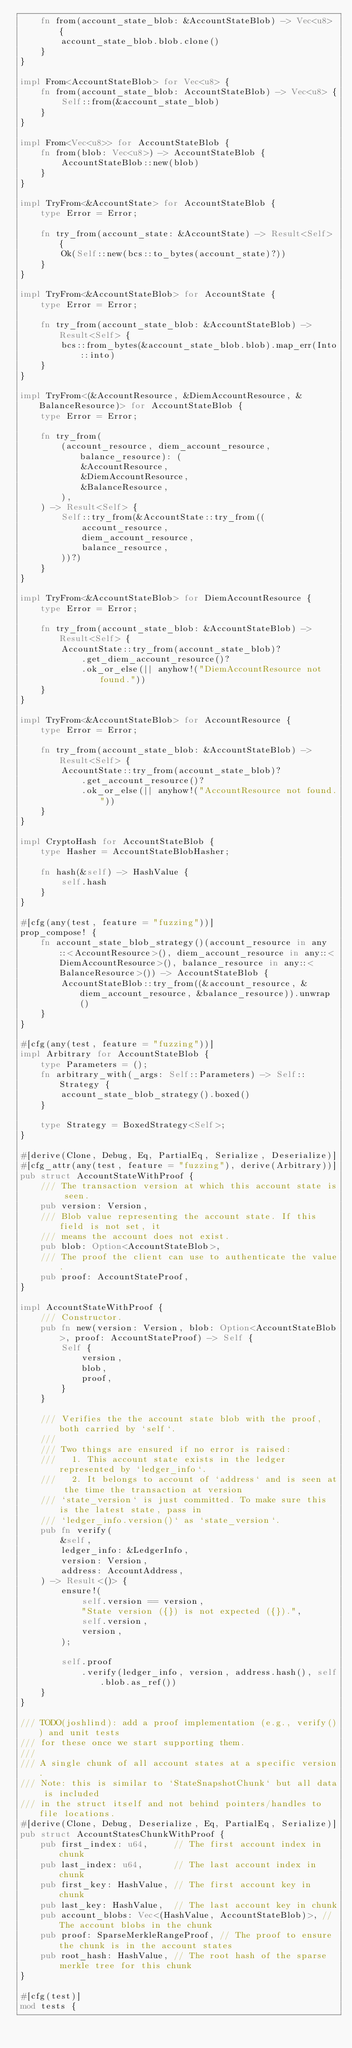Convert code to text. <code><loc_0><loc_0><loc_500><loc_500><_Rust_>    fn from(account_state_blob: &AccountStateBlob) -> Vec<u8> {
        account_state_blob.blob.clone()
    }
}

impl From<AccountStateBlob> for Vec<u8> {
    fn from(account_state_blob: AccountStateBlob) -> Vec<u8> {
        Self::from(&account_state_blob)
    }
}

impl From<Vec<u8>> for AccountStateBlob {
    fn from(blob: Vec<u8>) -> AccountStateBlob {
        AccountStateBlob::new(blob)
    }
}

impl TryFrom<&AccountState> for AccountStateBlob {
    type Error = Error;

    fn try_from(account_state: &AccountState) -> Result<Self> {
        Ok(Self::new(bcs::to_bytes(account_state)?))
    }
}

impl TryFrom<&AccountStateBlob> for AccountState {
    type Error = Error;

    fn try_from(account_state_blob: &AccountStateBlob) -> Result<Self> {
        bcs::from_bytes(&account_state_blob.blob).map_err(Into::into)
    }
}

impl TryFrom<(&AccountResource, &DiemAccountResource, &BalanceResource)> for AccountStateBlob {
    type Error = Error;

    fn try_from(
        (account_resource, diem_account_resource, balance_resource): (
            &AccountResource,
            &DiemAccountResource,
            &BalanceResource,
        ),
    ) -> Result<Self> {
        Self::try_from(&AccountState::try_from((
            account_resource,
            diem_account_resource,
            balance_resource,
        ))?)
    }
}

impl TryFrom<&AccountStateBlob> for DiemAccountResource {
    type Error = Error;

    fn try_from(account_state_blob: &AccountStateBlob) -> Result<Self> {
        AccountState::try_from(account_state_blob)?
            .get_diem_account_resource()?
            .ok_or_else(|| anyhow!("DiemAccountResource not found."))
    }
}

impl TryFrom<&AccountStateBlob> for AccountResource {
    type Error = Error;

    fn try_from(account_state_blob: &AccountStateBlob) -> Result<Self> {
        AccountState::try_from(account_state_blob)?
            .get_account_resource()?
            .ok_or_else(|| anyhow!("AccountResource not found."))
    }
}

impl CryptoHash for AccountStateBlob {
    type Hasher = AccountStateBlobHasher;

    fn hash(&self) -> HashValue {
        self.hash
    }
}

#[cfg(any(test, feature = "fuzzing"))]
prop_compose! {
    fn account_state_blob_strategy()(account_resource in any::<AccountResource>(), diem_account_resource in any::<DiemAccountResource>(), balance_resource in any::<BalanceResource>()) -> AccountStateBlob {
        AccountStateBlob::try_from((&account_resource, &diem_account_resource, &balance_resource)).unwrap()
    }
}

#[cfg(any(test, feature = "fuzzing"))]
impl Arbitrary for AccountStateBlob {
    type Parameters = ();
    fn arbitrary_with(_args: Self::Parameters) -> Self::Strategy {
        account_state_blob_strategy().boxed()
    }

    type Strategy = BoxedStrategy<Self>;
}

#[derive(Clone, Debug, Eq, PartialEq, Serialize, Deserialize)]
#[cfg_attr(any(test, feature = "fuzzing"), derive(Arbitrary))]
pub struct AccountStateWithProof {
    /// The transaction version at which this account state is seen.
    pub version: Version,
    /// Blob value representing the account state. If this field is not set, it
    /// means the account does not exist.
    pub blob: Option<AccountStateBlob>,
    /// The proof the client can use to authenticate the value.
    pub proof: AccountStateProof,
}

impl AccountStateWithProof {
    /// Constructor.
    pub fn new(version: Version, blob: Option<AccountStateBlob>, proof: AccountStateProof) -> Self {
        Self {
            version,
            blob,
            proof,
        }
    }

    /// Verifies the the account state blob with the proof, both carried by `self`.
    ///
    /// Two things are ensured if no error is raised:
    ///   1. This account state exists in the ledger represented by `ledger_info`.
    ///   2. It belongs to account of `address` and is seen at the time the transaction at version
    /// `state_version` is just committed. To make sure this is the latest state, pass in
    /// `ledger_info.version()` as `state_version`.
    pub fn verify(
        &self,
        ledger_info: &LedgerInfo,
        version: Version,
        address: AccountAddress,
    ) -> Result<()> {
        ensure!(
            self.version == version,
            "State version ({}) is not expected ({}).",
            self.version,
            version,
        );

        self.proof
            .verify(ledger_info, version, address.hash(), self.blob.as_ref())
    }
}

/// TODO(joshlind): add a proof implementation (e.g., verify()) and unit tests
/// for these once we start supporting them.
///
/// A single chunk of all account states at a specific version.
/// Note: this is similar to `StateSnapshotChunk` but all data is included
/// in the struct itself and not behind pointers/handles to file locations.
#[derive(Clone, Debug, Deserialize, Eq, PartialEq, Serialize)]
pub struct AccountStatesChunkWithProof {
    pub first_index: u64,     // The first account index in chunk
    pub last_index: u64,      // The last account index in chunk
    pub first_key: HashValue, // The first account key in chunk
    pub last_key: HashValue,  // The last account key in chunk
    pub account_blobs: Vec<(HashValue, AccountStateBlob)>, // The account blobs in the chunk
    pub proof: SparseMerkleRangeProof, // The proof to ensure the chunk is in the account states
    pub root_hash: HashValue, // The root hash of the sparse merkle tree for this chunk
}

#[cfg(test)]
mod tests {</code> 